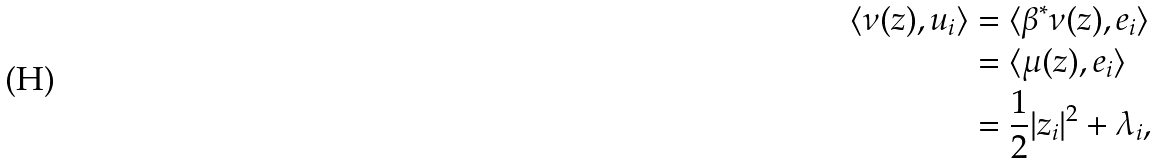Convert formula to latex. <formula><loc_0><loc_0><loc_500><loc_500>\langle \nu ( z ) , u _ { i } \rangle & = \langle \beta ^ { * } \nu ( z ) , e _ { i } \rangle \\ & = \langle \mu ( z ) , e _ { i } \rangle \\ & = \frac { 1 } { 2 } | z _ { i } | ^ { 2 } + \lambda _ { i } , \\</formula> 